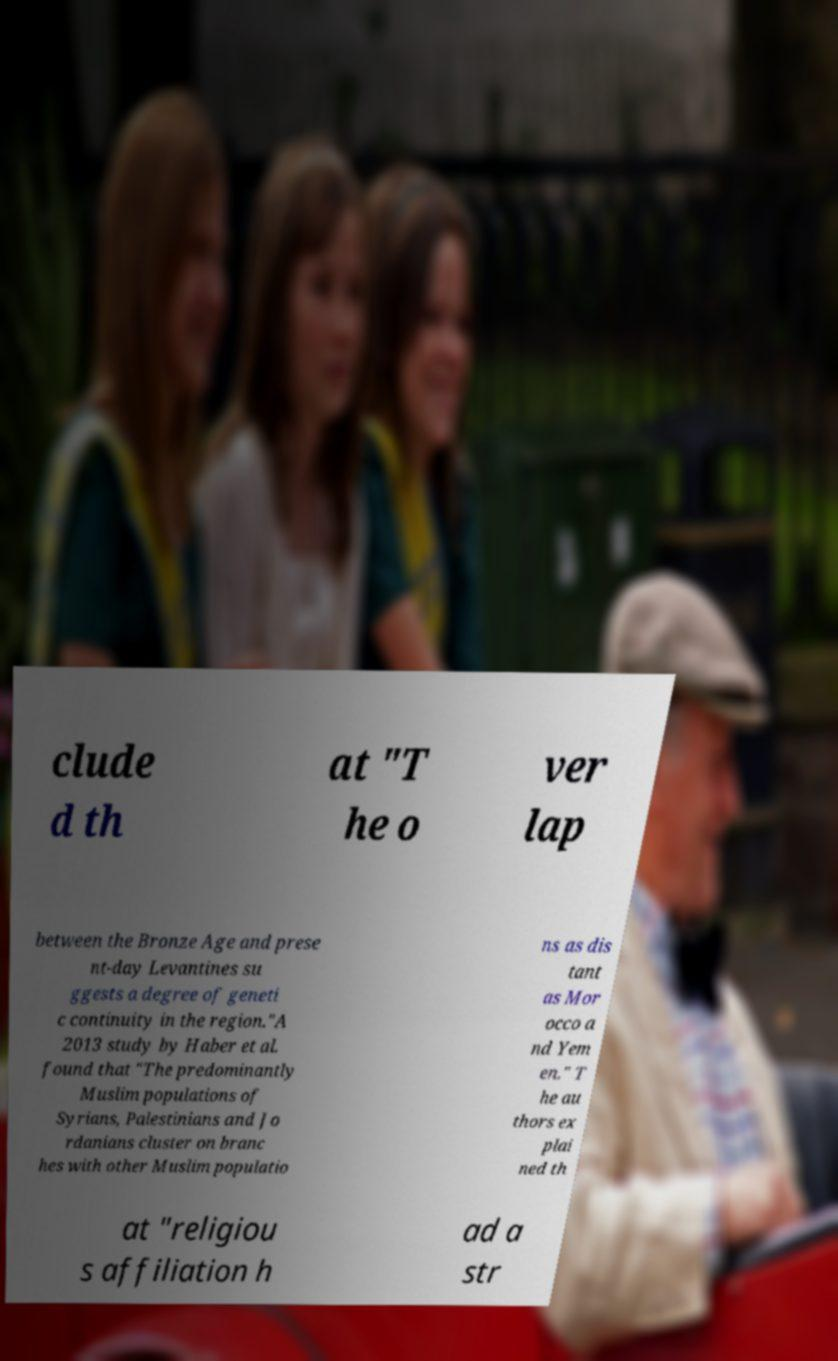There's text embedded in this image that I need extracted. Can you transcribe it verbatim? clude d th at "T he o ver lap between the Bronze Age and prese nt-day Levantines su ggests a degree of geneti c continuity in the region."A 2013 study by Haber et al. found that "The predominantly Muslim populations of Syrians, Palestinians and Jo rdanians cluster on branc hes with other Muslim populatio ns as dis tant as Mor occo a nd Yem en." T he au thors ex plai ned th at "religiou s affiliation h ad a str 